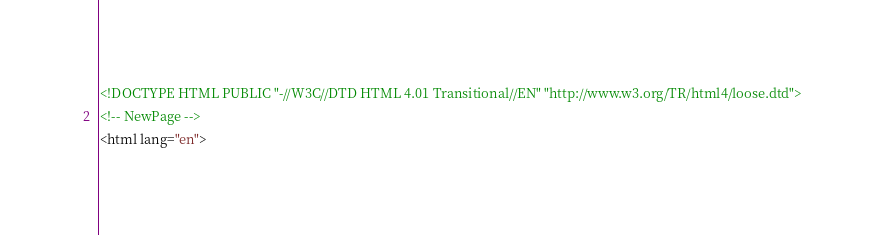Convert code to text. <code><loc_0><loc_0><loc_500><loc_500><_HTML_><!DOCTYPE HTML PUBLIC "-//W3C//DTD HTML 4.01 Transitional//EN" "http://www.w3.org/TR/html4/loose.dtd">
<!-- NewPage -->
<html lang="en"></code> 